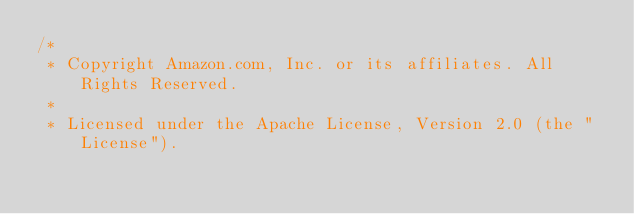Convert code to text. <code><loc_0><loc_0><loc_500><loc_500><_C#_>/*
 * Copyright Amazon.com, Inc. or its affiliates. All Rights Reserved.
 * 
 * Licensed under the Apache License, Version 2.0 (the "License").</code> 